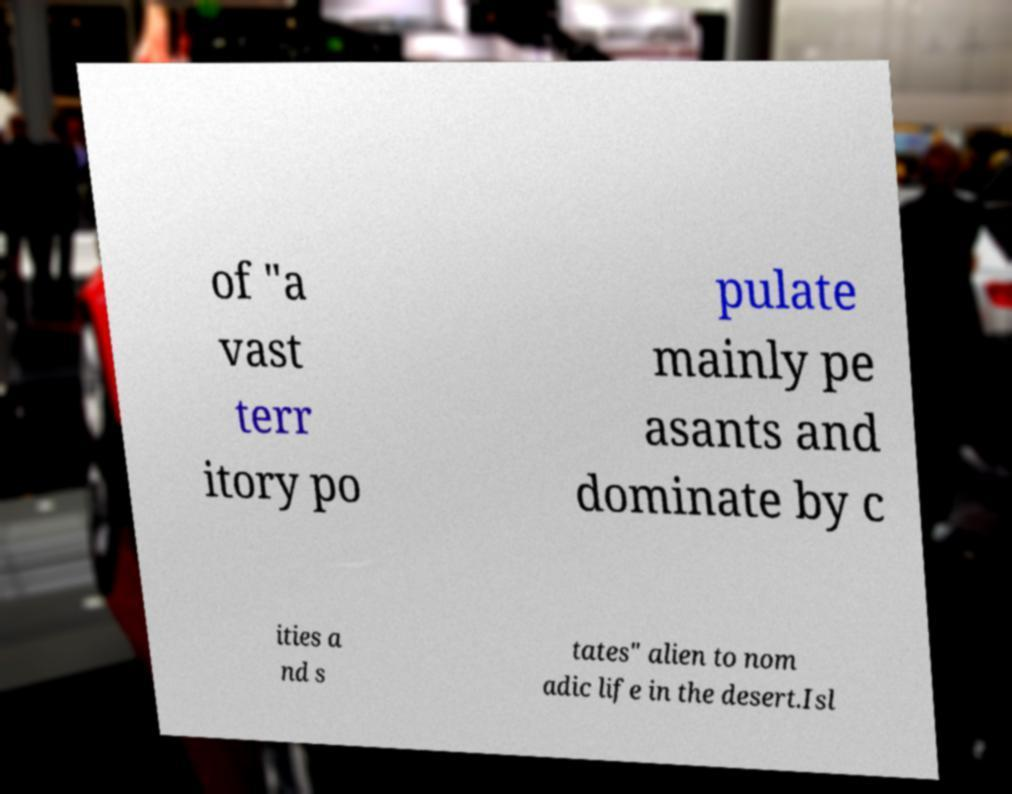What messages or text are displayed in this image? I need them in a readable, typed format. of "a vast terr itory po pulate mainly pe asants and dominate by c ities a nd s tates" alien to nom adic life in the desert.Isl 